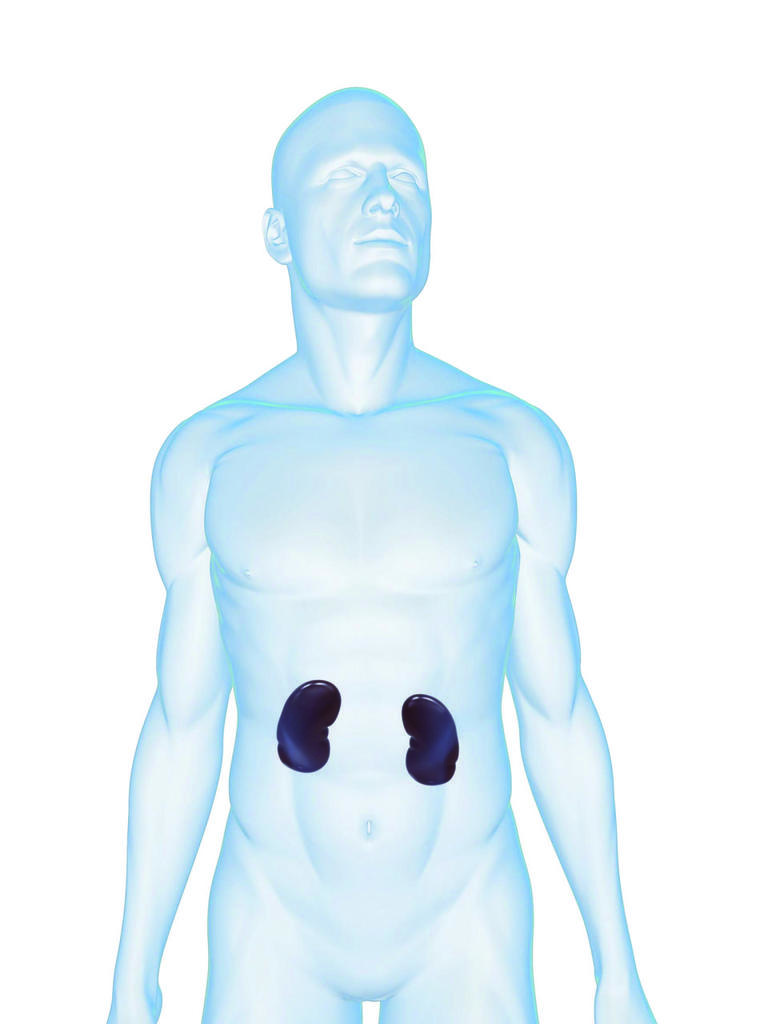What is the main subject of the image? There is a depiction of a person in the center of the image. How many quince trees are present in the image? There are no quince trees visible in the image; the main subject is a person. 